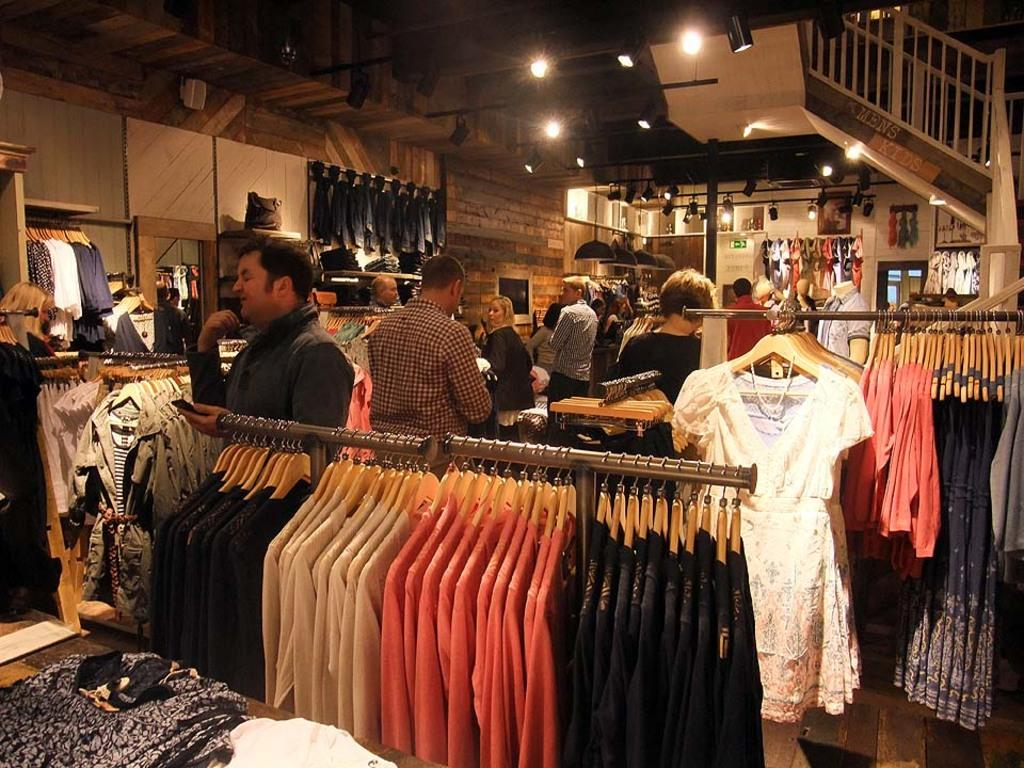What is hanging in the foreground of the image? There are clothes hung in the foreground of the image. What can be seen in the background of the image? There are people, clothes, stairs, and lamps visible in the background of the image. Can you describe the architectural feature in the background? Yes, there are stairs in the background of the image. What type of lighting is present in the background? There are lamps in the background of the image. What type of vein can be seen running through the clothes in the image? There is no vein visible in the image, as veins are not present in clothing. 